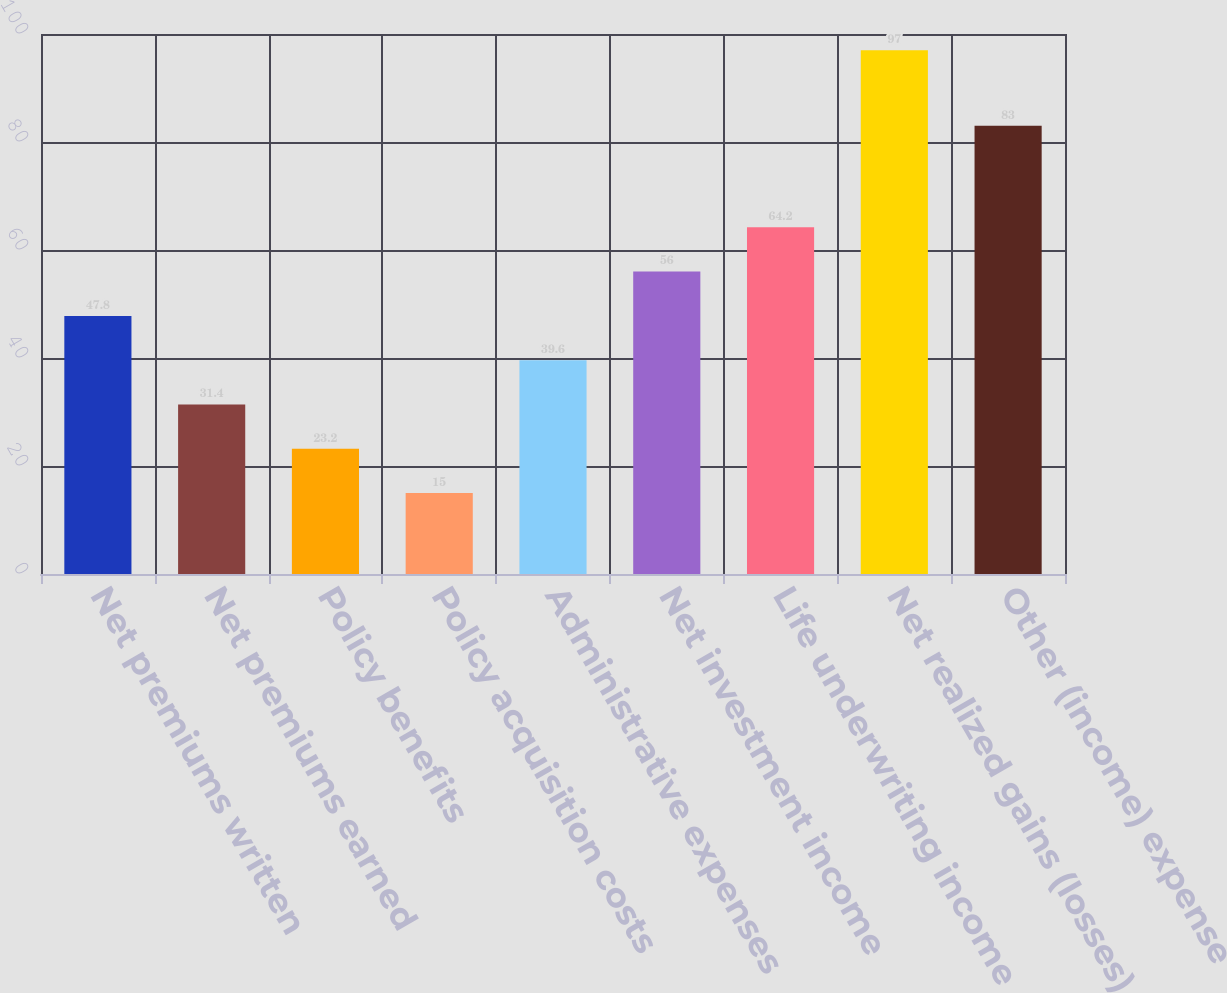Convert chart to OTSL. <chart><loc_0><loc_0><loc_500><loc_500><bar_chart><fcel>Net premiums written<fcel>Net premiums earned<fcel>Policy benefits<fcel>Policy acquisition costs<fcel>Administrative expenses<fcel>Net investment income<fcel>Life underwriting income<fcel>Net realized gains (losses)<fcel>Other (income) expense<nl><fcel>47.8<fcel>31.4<fcel>23.2<fcel>15<fcel>39.6<fcel>56<fcel>64.2<fcel>97<fcel>83<nl></chart> 